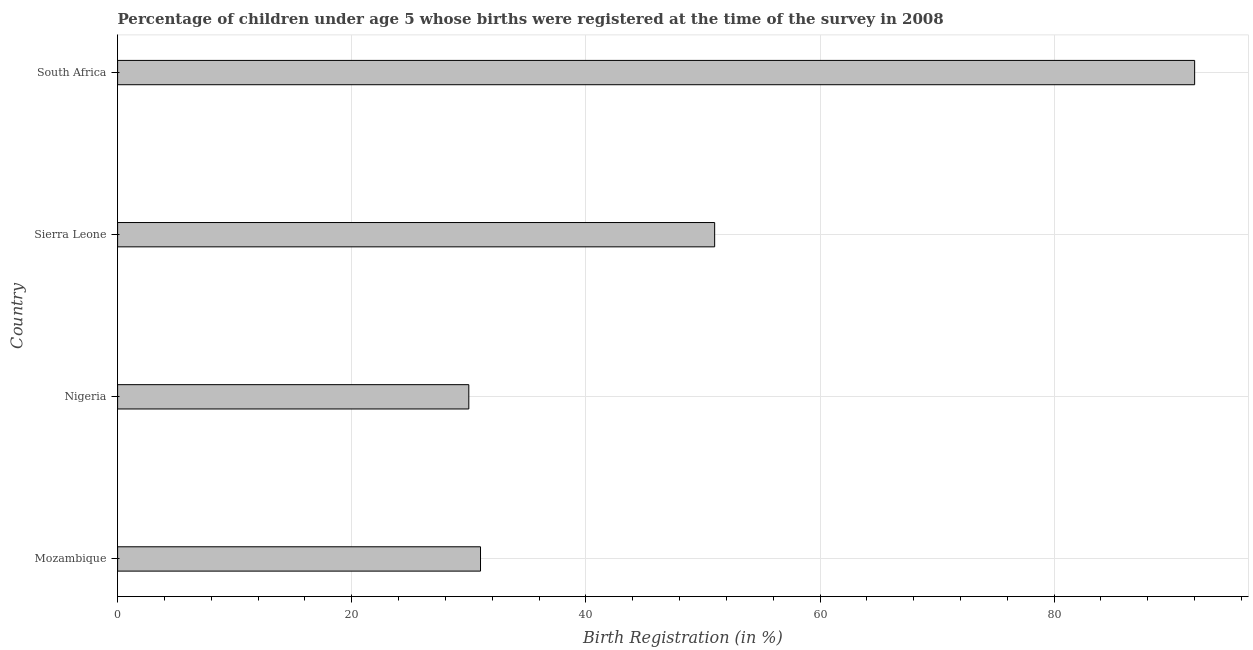Does the graph contain any zero values?
Your response must be concise. No. What is the title of the graph?
Your answer should be very brief. Percentage of children under age 5 whose births were registered at the time of the survey in 2008. What is the label or title of the X-axis?
Keep it short and to the point. Birth Registration (in %). Across all countries, what is the maximum birth registration?
Your answer should be very brief. 92. In which country was the birth registration maximum?
Your answer should be very brief. South Africa. In which country was the birth registration minimum?
Provide a short and direct response. Nigeria. What is the sum of the birth registration?
Keep it short and to the point. 204. What is the difference between the birth registration in Mozambique and South Africa?
Provide a succinct answer. -61. What is the average birth registration per country?
Provide a succinct answer. 51. In how many countries, is the birth registration greater than 80 %?
Give a very brief answer. 1. What is the ratio of the birth registration in Mozambique to that in Sierra Leone?
Your response must be concise. 0.61. Is the difference between the birth registration in Nigeria and Sierra Leone greater than the difference between any two countries?
Your answer should be very brief. No. What is the difference between the highest and the second highest birth registration?
Ensure brevity in your answer.  41. Is the sum of the birth registration in Mozambique and Sierra Leone greater than the maximum birth registration across all countries?
Give a very brief answer. No. In how many countries, is the birth registration greater than the average birth registration taken over all countries?
Your answer should be compact. 1. How many bars are there?
Ensure brevity in your answer.  4. Are all the bars in the graph horizontal?
Keep it short and to the point. Yes. Are the values on the major ticks of X-axis written in scientific E-notation?
Offer a terse response. No. What is the Birth Registration (in %) of Mozambique?
Give a very brief answer. 31. What is the Birth Registration (in %) of Nigeria?
Provide a short and direct response. 30. What is the Birth Registration (in %) of South Africa?
Keep it short and to the point. 92. What is the difference between the Birth Registration (in %) in Mozambique and Nigeria?
Ensure brevity in your answer.  1. What is the difference between the Birth Registration (in %) in Mozambique and South Africa?
Your response must be concise. -61. What is the difference between the Birth Registration (in %) in Nigeria and Sierra Leone?
Your answer should be compact. -21. What is the difference between the Birth Registration (in %) in Nigeria and South Africa?
Provide a short and direct response. -62. What is the difference between the Birth Registration (in %) in Sierra Leone and South Africa?
Keep it short and to the point. -41. What is the ratio of the Birth Registration (in %) in Mozambique to that in Nigeria?
Your answer should be very brief. 1.03. What is the ratio of the Birth Registration (in %) in Mozambique to that in Sierra Leone?
Provide a short and direct response. 0.61. What is the ratio of the Birth Registration (in %) in Mozambique to that in South Africa?
Ensure brevity in your answer.  0.34. What is the ratio of the Birth Registration (in %) in Nigeria to that in Sierra Leone?
Keep it short and to the point. 0.59. What is the ratio of the Birth Registration (in %) in Nigeria to that in South Africa?
Your answer should be compact. 0.33. What is the ratio of the Birth Registration (in %) in Sierra Leone to that in South Africa?
Your response must be concise. 0.55. 